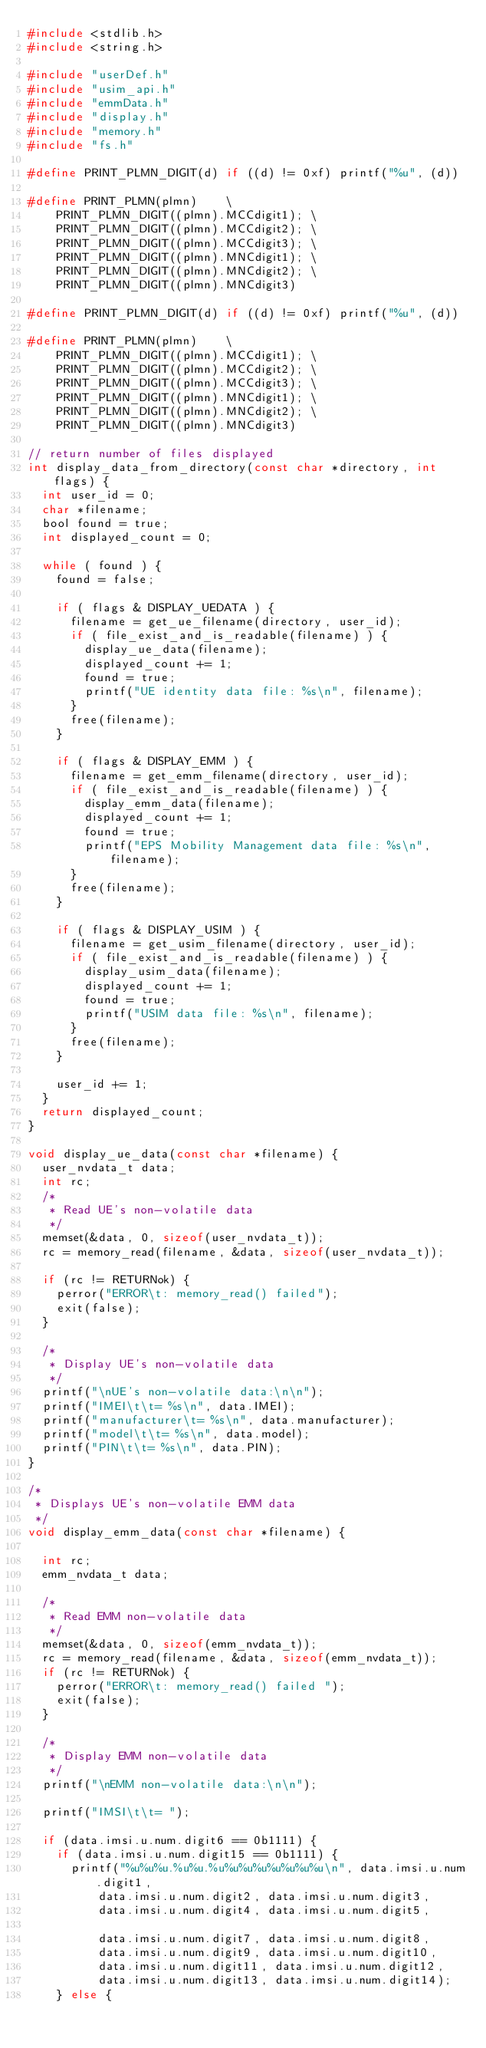<code> <loc_0><loc_0><loc_500><loc_500><_C_>#include <stdlib.h>
#include <string.h>

#include "userDef.h"
#include "usim_api.h"
#include "emmData.h"
#include "display.h"
#include "memory.h"
#include "fs.h"

#define PRINT_PLMN_DIGIT(d) if ((d) != 0xf) printf("%u", (d))

#define PRINT_PLMN(plmn)    \
    PRINT_PLMN_DIGIT((plmn).MCCdigit1); \
    PRINT_PLMN_DIGIT((plmn).MCCdigit2); \
    PRINT_PLMN_DIGIT((plmn).MCCdigit3); \
    PRINT_PLMN_DIGIT((plmn).MNCdigit1); \
    PRINT_PLMN_DIGIT((plmn).MNCdigit2); \
    PRINT_PLMN_DIGIT((plmn).MNCdigit3)

#define PRINT_PLMN_DIGIT(d) if ((d) != 0xf) printf("%u", (d))

#define PRINT_PLMN(plmn)    \
    PRINT_PLMN_DIGIT((plmn).MCCdigit1); \
    PRINT_PLMN_DIGIT((plmn).MCCdigit2); \
    PRINT_PLMN_DIGIT((plmn).MCCdigit3); \
    PRINT_PLMN_DIGIT((plmn).MNCdigit1); \
    PRINT_PLMN_DIGIT((plmn).MNCdigit2); \
    PRINT_PLMN_DIGIT((plmn).MNCdigit3)

// return number of files displayed
int display_data_from_directory(const char *directory, int flags) {
	int user_id = 0;
	char *filename;
	bool found = true;
  int displayed_count = 0;

	while ( found ) {
		found = false;

		if ( flags & DISPLAY_UEDATA ) {
			filename = get_ue_filename(directory, user_id);
			if ( file_exist_and_is_readable(filename) ) {
				display_ue_data(filename);
				displayed_count += 1;
				found = true;
				printf("UE identity data file: %s\n", filename);
			}
			free(filename);
		}

		if ( flags & DISPLAY_EMM ) {
			filename = get_emm_filename(directory, user_id);
			if ( file_exist_and_is_readable(filename) ) {
				display_emm_data(filename);
				displayed_count += 1;
				found = true;
				printf("EPS Mobility Management data file: %s\n", filename);
			}
			free(filename);
		}

		if ( flags & DISPLAY_USIM ) {
			filename = get_usim_filename(directory, user_id);
			if ( file_exist_and_is_readable(filename) ) {
				display_usim_data(filename);
				displayed_count += 1;
				found = true;
				printf("USIM data file: %s\n", filename);
			}
			free(filename);
		}

		user_id += 1;
	}
	return displayed_count;
}

void display_ue_data(const char *filename) {
	user_nvdata_t data;
	int rc;
	/*
	 * Read UE's non-volatile data
	 */
	memset(&data, 0, sizeof(user_nvdata_t));
	rc = memory_read(filename, &data, sizeof(user_nvdata_t));

	if (rc != RETURNok) {
		perror("ERROR\t: memory_read() failed");
		exit(false);
	}

	/*
	 * Display UE's non-volatile data
	 */
	printf("\nUE's non-volatile data:\n\n");
	printf("IMEI\t\t= %s\n", data.IMEI);
	printf("manufacturer\t= %s\n", data.manufacturer);
	printf("model\t\t= %s\n", data.model);
	printf("PIN\t\t= %s\n", data.PIN);
}

/*
 * Displays UE's non-volatile EMM data
 */
void display_emm_data(const char *filename) {

	int rc;
	emm_nvdata_t data;

	/*
	 * Read EMM non-volatile data
	 */
	memset(&data, 0, sizeof(emm_nvdata_t));
	rc = memory_read(filename, &data, sizeof(emm_nvdata_t));
	if (rc != RETURNok) {
		perror("ERROR\t: memory_read() failed ");
		exit(false);
	}

	/*
	 * Display EMM non-volatile data
	 */
	printf("\nEMM non-volatile data:\n\n");

	printf("IMSI\t\t= ");

	if (data.imsi.u.num.digit6 == 0b1111) {
		if (data.imsi.u.num.digit15 == 0b1111) {
			printf("%u%u%u.%u%u.%u%u%u%u%u%u%u%u\n", data.imsi.u.num.digit1,
					data.imsi.u.num.digit2, data.imsi.u.num.digit3,
					data.imsi.u.num.digit4, data.imsi.u.num.digit5,

					data.imsi.u.num.digit7, data.imsi.u.num.digit8,
					data.imsi.u.num.digit9, data.imsi.u.num.digit10,
					data.imsi.u.num.digit11, data.imsi.u.num.digit12,
					data.imsi.u.num.digit13, data.imsi.u.num.digit14);
		} else {</code> 